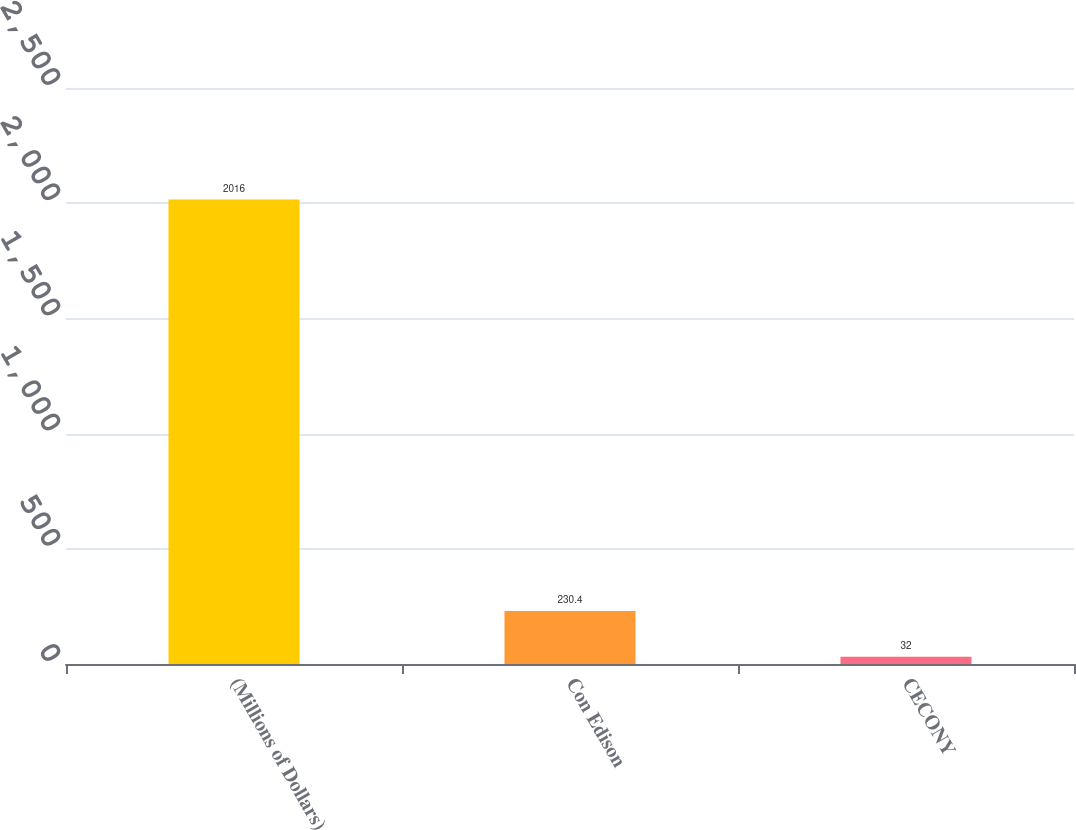Convert chart to OTSL. <chart><loc_0><loc_0><loc_500><loc_500><bar_chart><fcel>(Millions of Dollars)<fcel>Con Edison<fcel>CECONY<nl><fcel>2016<fcel>230.4<fcel>32<nl></chart> 